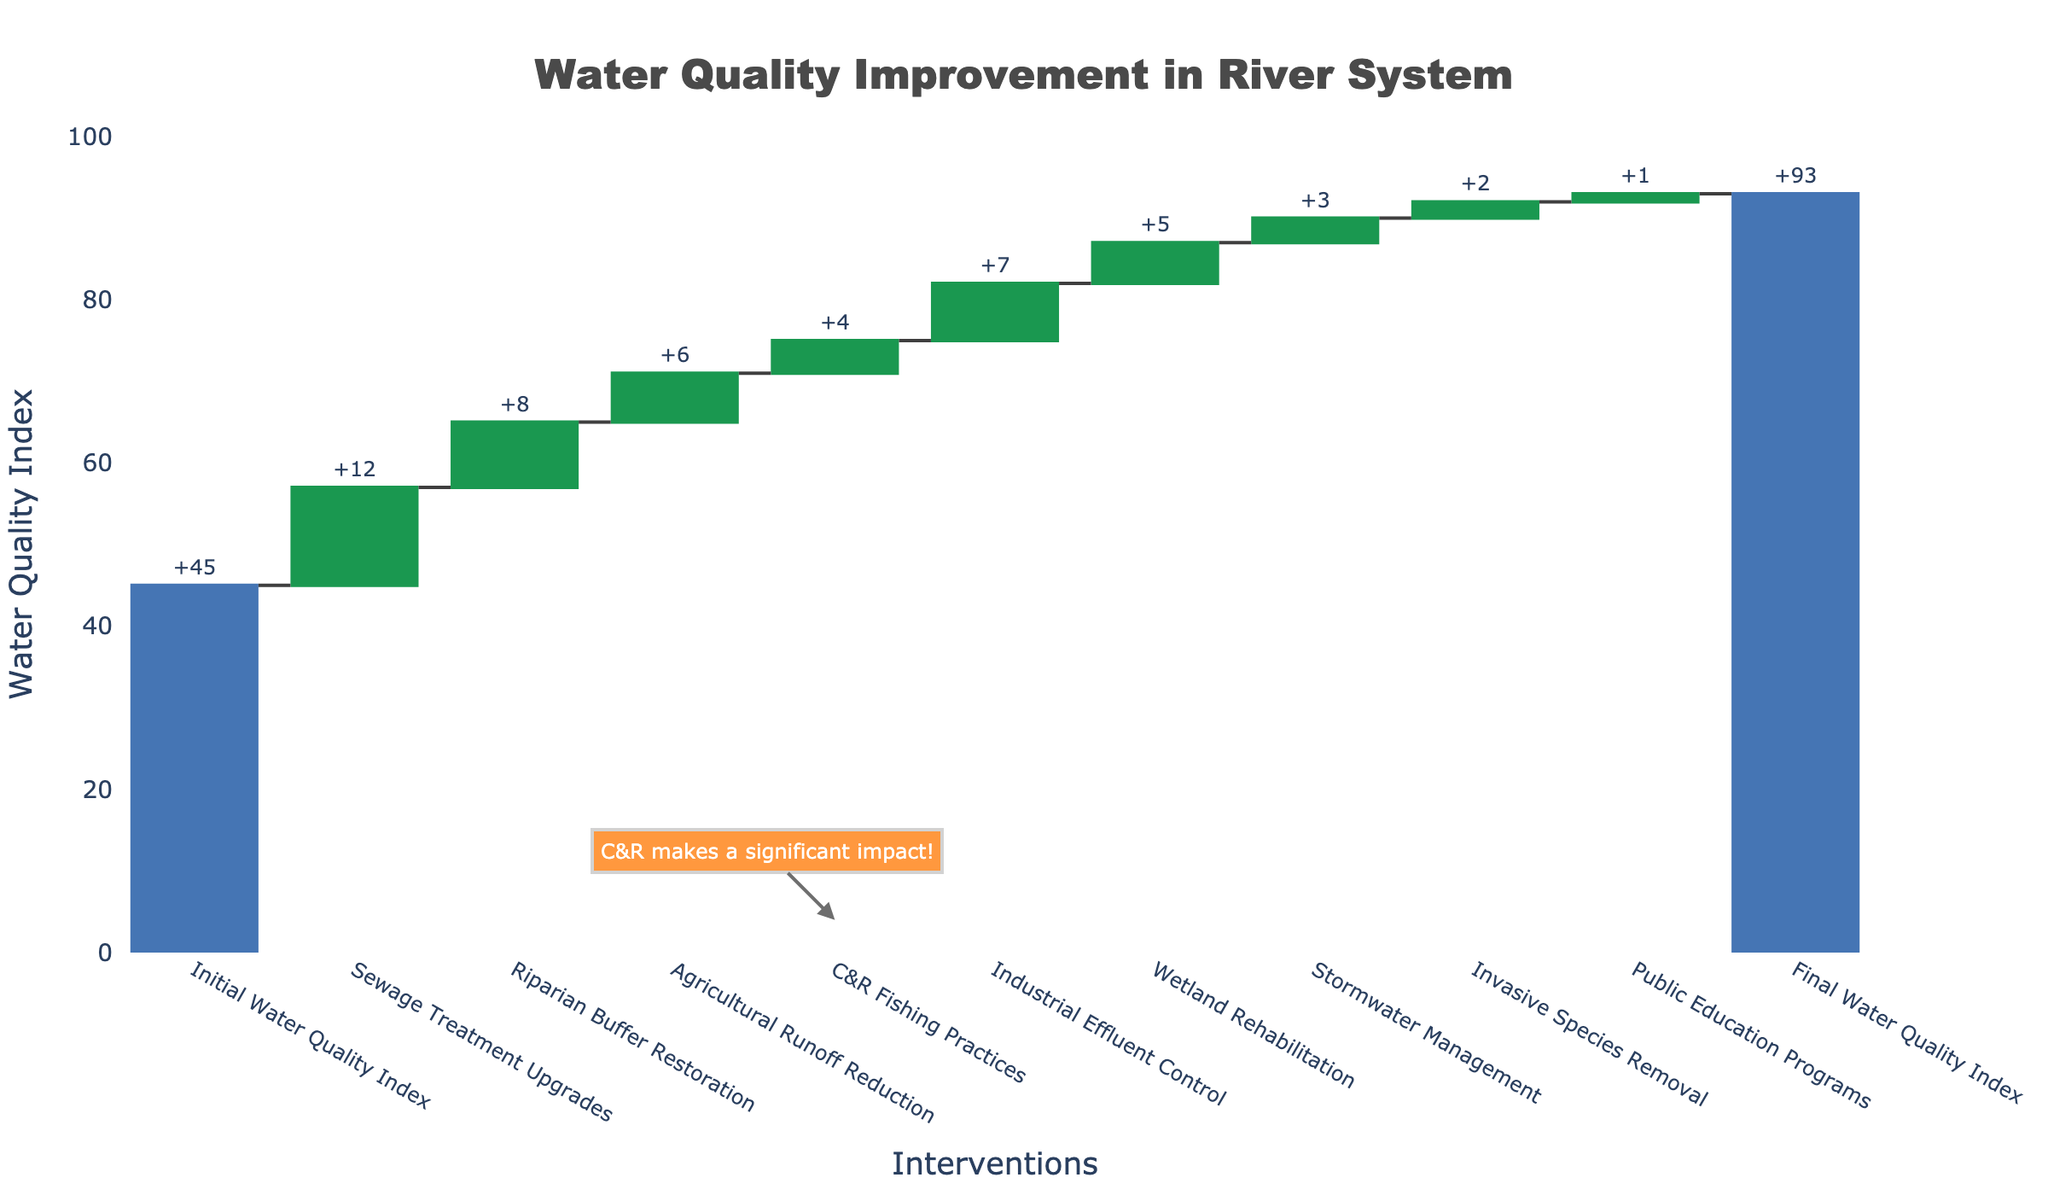What's the title of the figure? The title is located at the top of the figure and is often in a larger font to indicate it is the main heading. In this case, it reads "Water Quality Improvement in River System".
Answer: Water Quality Improvement in River System How many interventions are shown in the figure? By counting the number of items listed on the x-axis that represent individual interventions, we can determine the total number. Since there are 9 interventions listed between the initial and final water quality index, we have: Sewage Treatment Upgrades, Riparian Buffer Restoration, Agricultural Runoff Reduction, C&R Fishing Practices, Industrial Effluent Control, Wetland Rehabilitation, Stormwater Management, Invasive Species Removal, and Public Education Programs.
Answer: 9 What is the final water quality index after all interventions? The final water quality index is represented by the last bar, labeled "Final Water Quality Index" on the x-axis. This value is indicated at the top of the bar, which is 93.
Answer: 93 Which intervention contributed the least to the water quality improvement? By examining the heights of the bars representing each intervention, the smallest contribution comes from the intervention with the smallest bar height. This is "Public Education Programs," which adds 1 unit to the water quality index.
Answer: Public Education Programs How much did C&R Fishing Practices contribute to the water quality improvement? By identifying the bar labeled "C&R Fishing Practices", we can see its height indicates the contribution, which is 4 units on the y-axis. Additionally, this bar is highlighted with an annotation that states, "C&R makes a significant impact!"
Answer: 4 What is the total improvement in the water quality index from initial to final states? Subtract the initial water quality index from the final water quality index to find the total improvement. Initial is 45 and final is 93. So, the total improvement is 93 - 45.
Answer: 48 How does the contribution of Industrial Effluent Control compare to Wetland Rehabilitation? By comparing the heights of the bars, Industrial Effluent Control is 7 units whereas Wetland Rehabilitation is 5 units. Industrial Effluent Control contributes more than Wetland Rehabilitation by a difference of 7 - 5.
Answer: Industrial Effluent Control contributes 2 more units than Wetland Rehabilitation If C&R Fishing Practices were not implemented, what would the final water quality index be? The contribution of C&R Fishing Practices is 4 units. Subtract this from the final water quality index of 93. So, the final index without this practice would be 93 - 4.
Answer: 89 Which interventions together contribute the highest improvement in water quality? Sum up the contributions of each intervention and compare different groups. The highest individual contributions are from Sewage Treatment Upgrades (12), Industrial Effluent Control (7), and Riparian Buffer Restoration (8). Adding these together: 12 + 7 + 8 = 27 units. This combination provides the highest improvement.
Answer: Sewage Treatment Upgrades, Industrial Effluent Control, and Riparian Buffer Restoration What color is used for increasing interventions in the chart? The increasing interventions are represented by bars that are colored green, which is visually discernible from the other colors used for bars that decrease or represent totals.
Answer: Green 